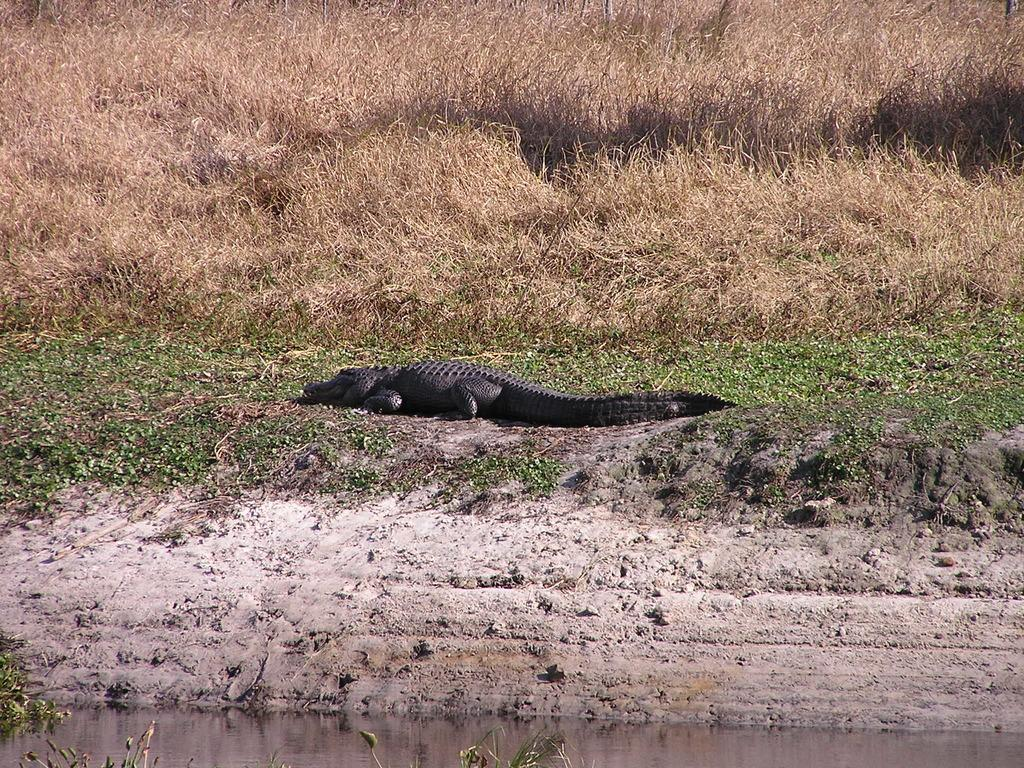What animal can be seen in the image? There is a crocodile in the image. Where is the crocodile located? The crocodile is on the ground in the image. What type of environment is depicted in the image? There is water, mud, and grass on the ground in the image. What part of the building can be seen in the image? There is no building present in the image; it features a crocodile on the ground in a natural environment. 